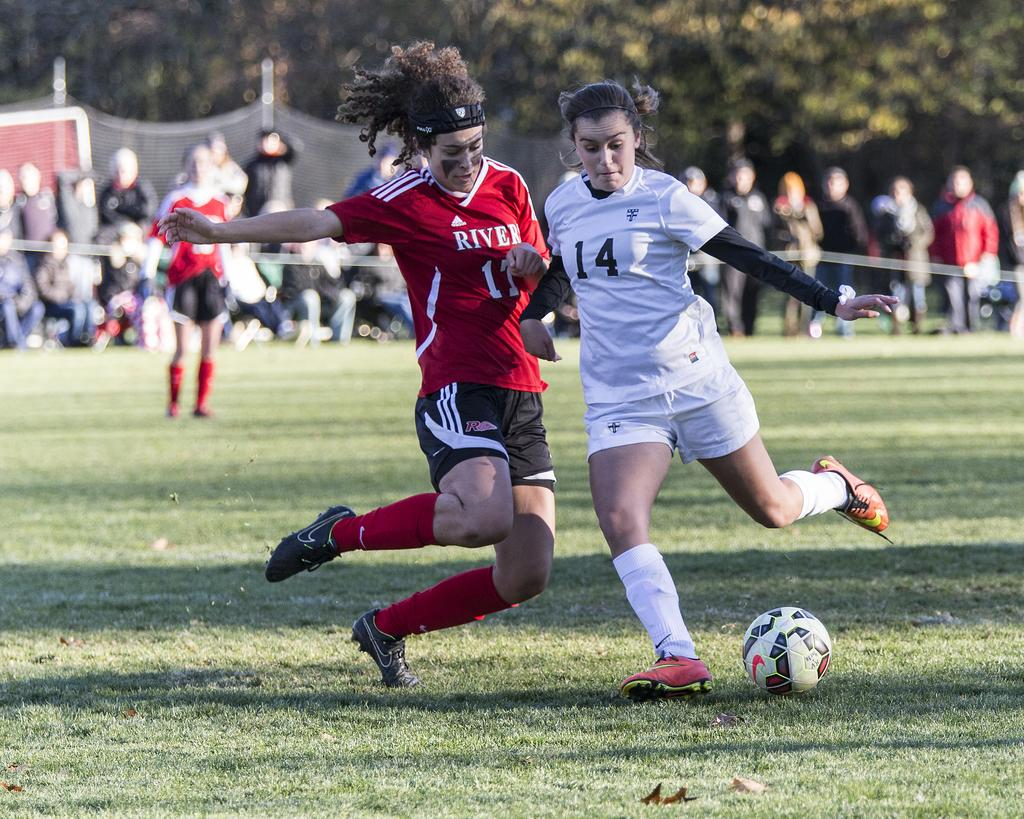What are the two persons in the image doing? The two persons are running and playing football. Can you describe the background of the image? There is a group of persons in the background, as well as a tree and a net. What type of needle can be seen in the image? There is no needle present in the image. How many deer are visible in the image? There are no deer present in the image. 